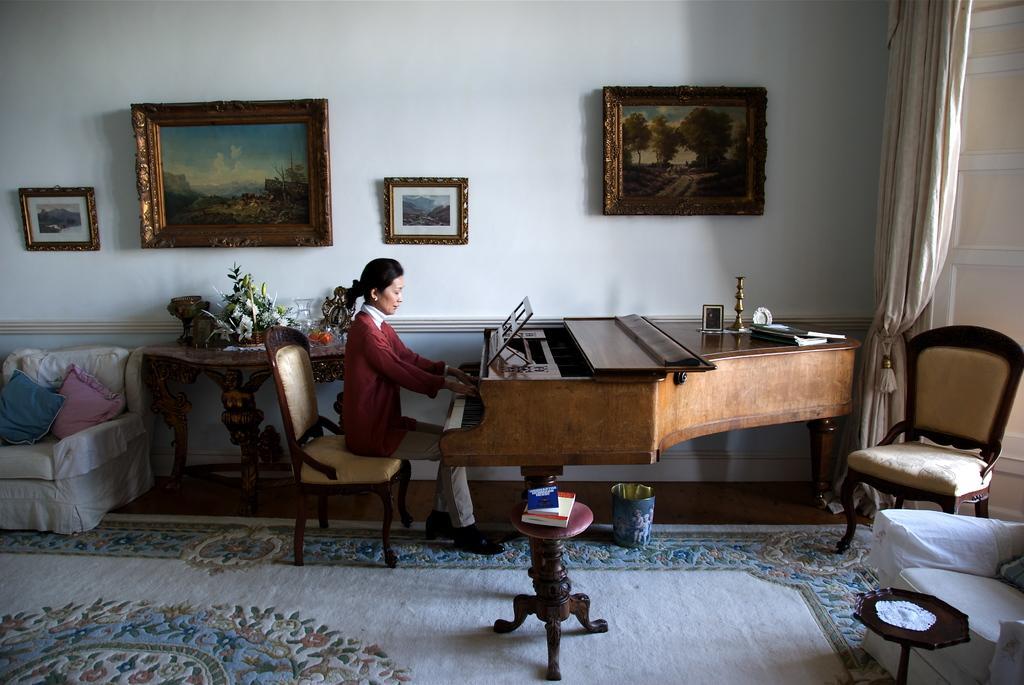In one or two sentences, can you explain what this image depicts? The picture consists of a woman sat on chair playing piano ,this seems to be living room,on the right side there are chair and sofa and on the left side there is sofa and on the wall there are paintings. 